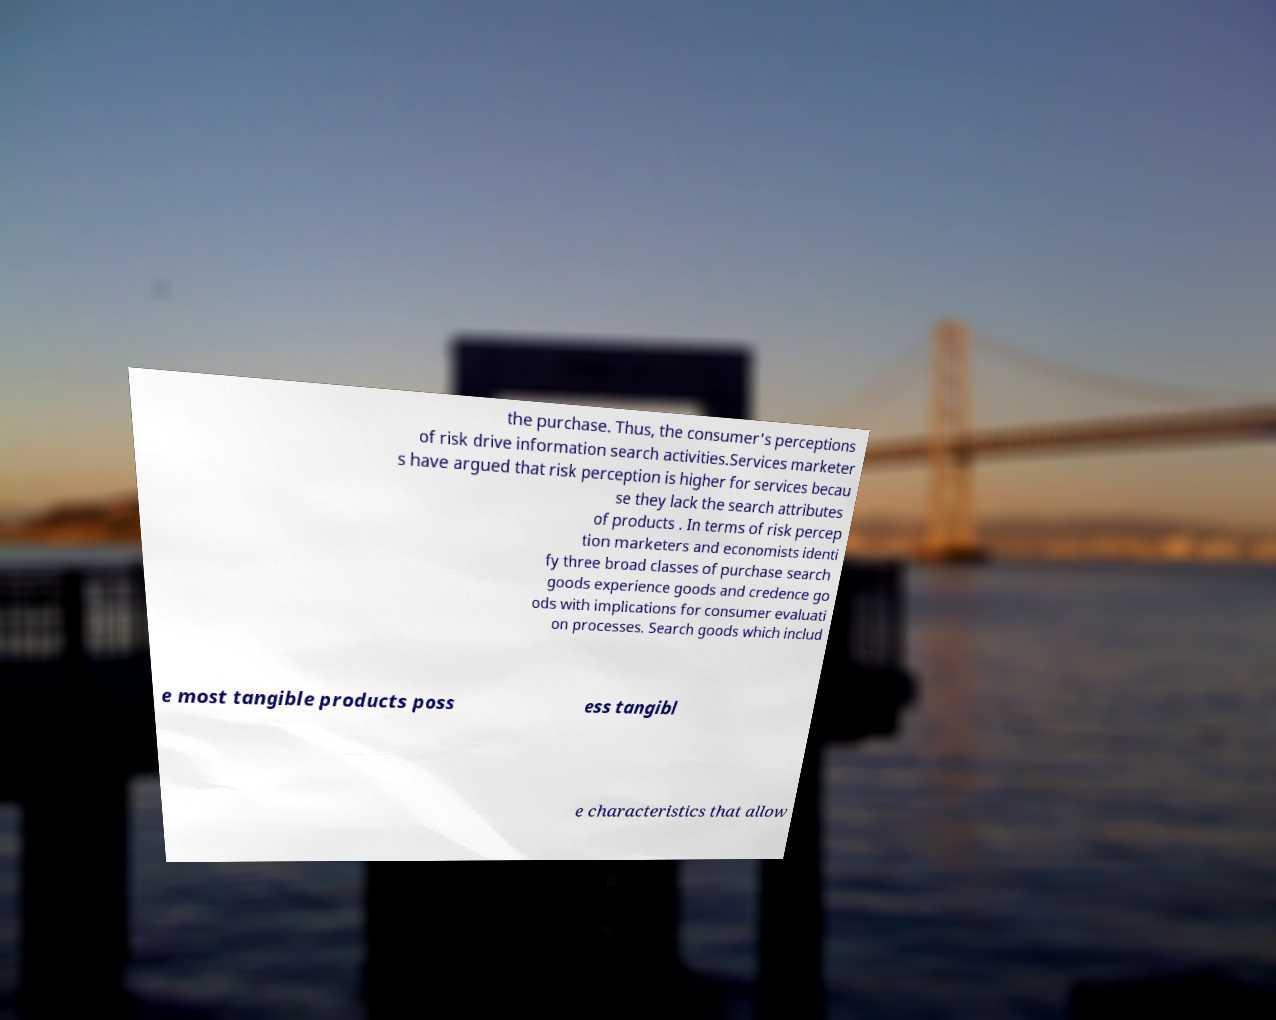Please identify and transcribe the text found in this image. the purchase. Thus, the consumer's perceptions of risk drive information search activities.Services marketer s have argued that risk perception is higher for services becau se they lack the search attributes of products . In terms of risk percep tion marketers and economists identi fy three broad classes of purchase search goods experience goods and credence go ods with implications for consumer evaluati on processes. Search goods which includ e most tangible products poss ess tangibl e characteristics that allow 